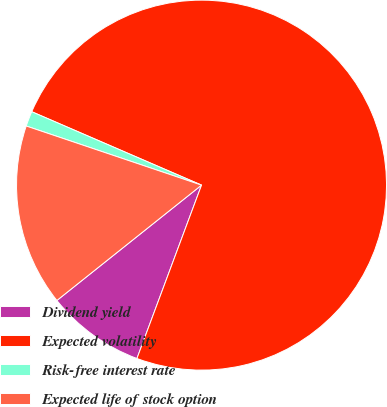Convert chart to OTSL. <chart><loc_0><loc_0><loc_500><loc_500><pie_chart><fcel>Dividend yield<fcel>Expected volatility<fcel>Risk-free interest rate<fcel>Expected life of stock option<nl><fcel>8.61%<fcel>74.18%<fcel>1.32%<fcel>15.89%<nl></chart> 